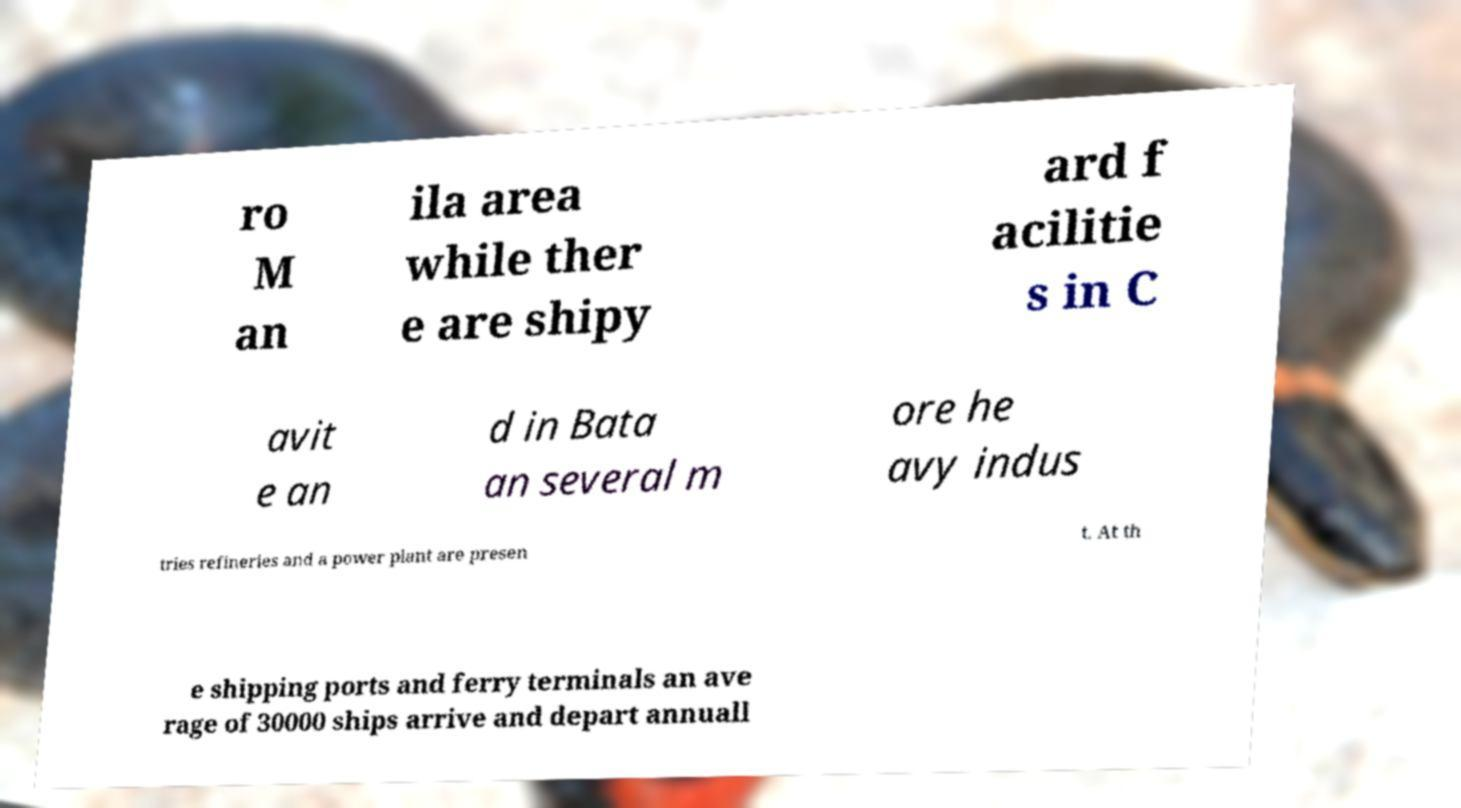Can you read and provide the text displayed in the image?This photo seems to have some interesting text. Can you extract and type it out for me? ro M an ila area while ther e are shipy ard f acilitie s in C avit e an d in Bata an several m ore he avy indus tries refineries and a power plant are presen t. At th e shipping ports and ferry terminals an ave rage of 30000 ships arrive and depart annuall 